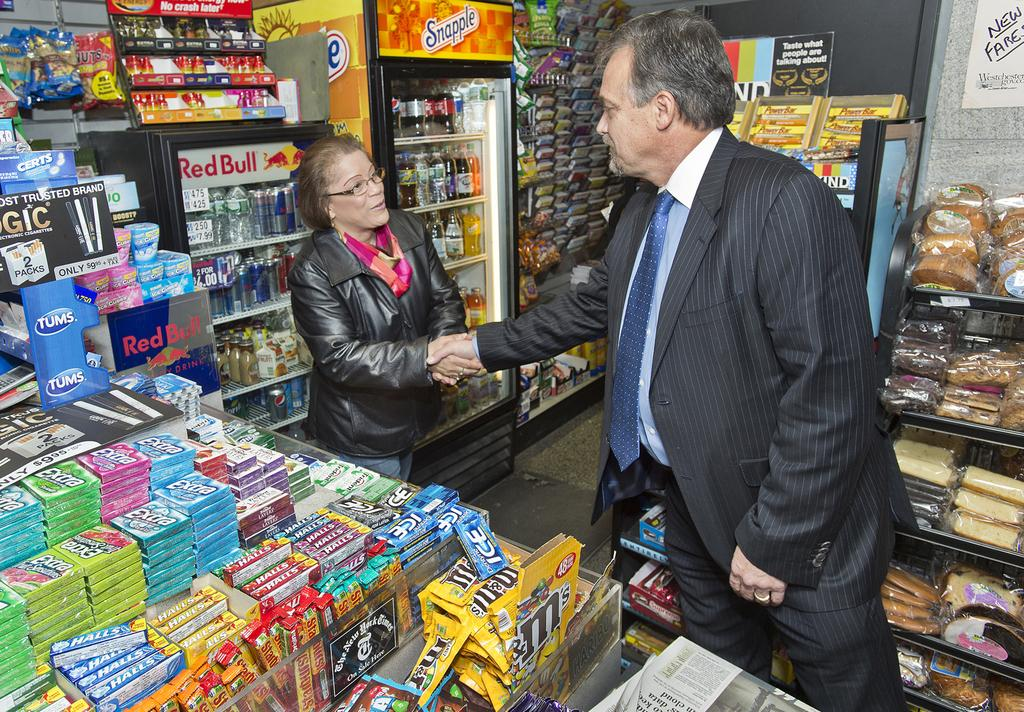<image>
Create a compact narrative representing the image presented. Man shaking hands with a woman in front of a Red Bull freezer. 